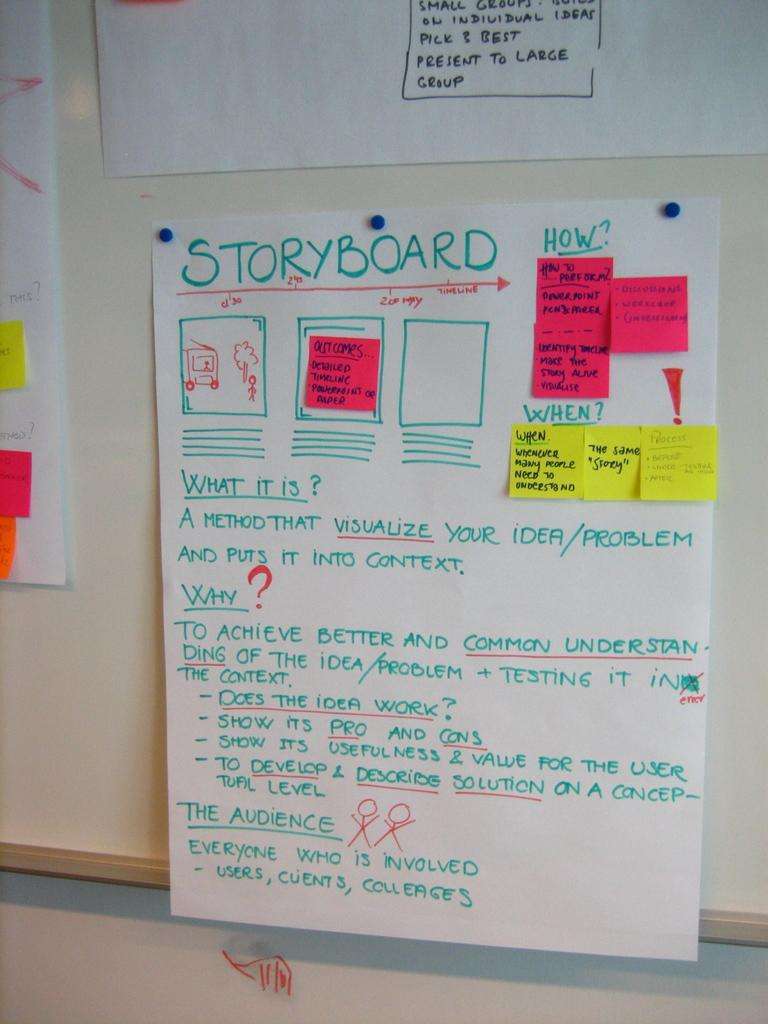<image>
Provide a brief description of the given image. A bulletin board with a storyboard  pinned to it. 